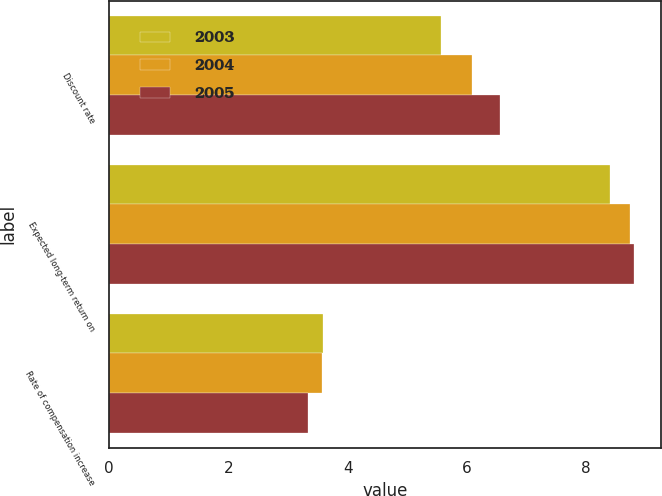<chart> <loc_0><loc_0><loc_500><loc_500><stacked_bar_chart><ecel><fcel>Discount rate<fcel>Expected long-term return on<fcel>Rate of compensation increase<nl><fcel>2003<fcel>5.57<fcel>8.41<fcel>3.59<nl><fcel>2004<fcel>6.08<fcel>8.73<fcel>3.57<nl><fcel>2005<fcel>6.56<fcel>8.81<fcel>3.33<nl></chart> 